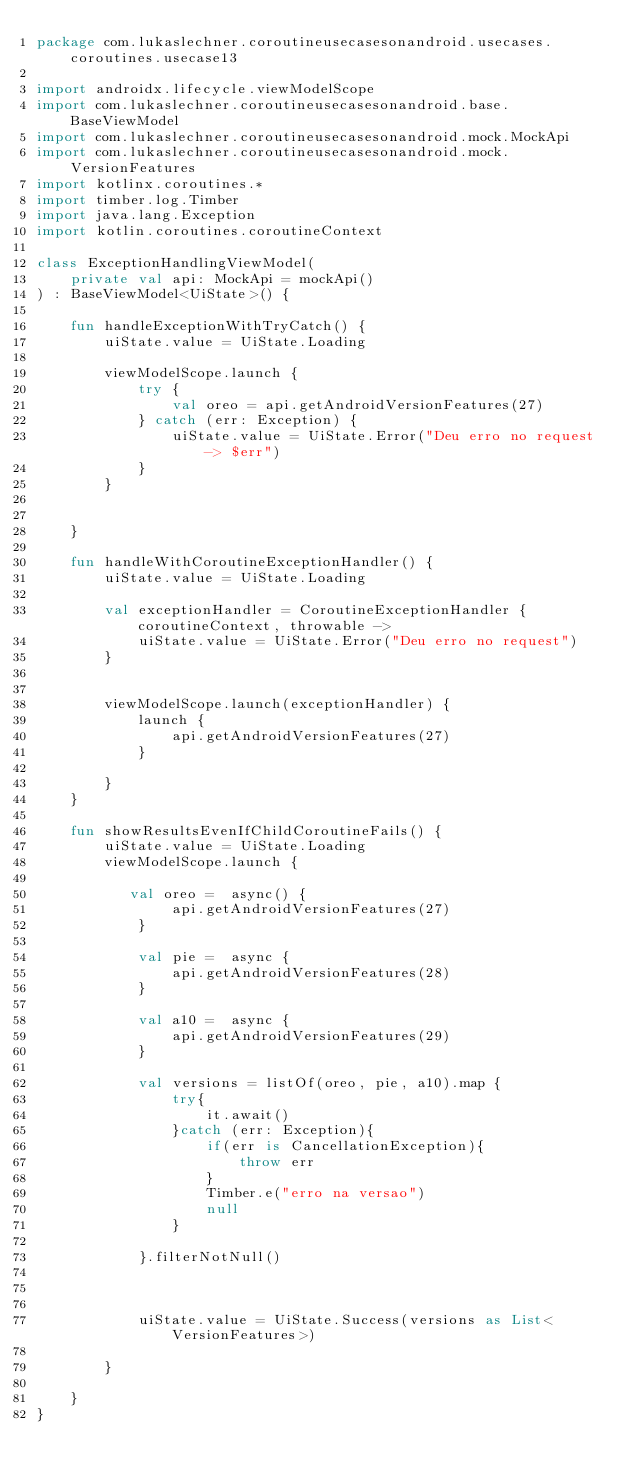Convert code to text. <code><loc_0><loc_0><loc_500><loc_500><_Kotlin_>package com.lukaslechner.coroutineusecasesonandroid.usecases.coroutines.usecase13

import androidx.lifecycle.viewModelScope
import com.lukaslechner.coroutineusecasesonandroid.base.BaseViewModel
import com.lukaslechner.coroutineusecasesonandroid.mock.MockApi
import com.lukaslechner.coroutineusecasesonandroid.mock.VersionFeatures
import kotlinx.coroutines.*
import timber.log.Timber
import java.lang.Exception
import kotlin.coroutines.coroutineContext

class ExceptionHandlingViewModel(
    private val api: MockApi = mockApi()
) : BaseViewModel<UiState>() {

    fun handleExceptionWithTryCatch() {
        uiState.value = UiState.Loading

        viewModelScope.launch {
            try {
                val oreo = api.getAndroidVersionFeatures(27)
            } catch (err: Exception) {
                uiState.value = UiState.Error("Deu erro no request -> $err")
            }
        }


    }

    fun handleWithCoroutineExceptionHandler() {
        uiState.value = UiState.Loading

        val exceptionHandler = CoroutineExceptionHandler { coroutineContext, throwable ->
            uiState.value = UiState.Error("Deu erro no request")
        }


        viewModelScope.launch(exceptionHandler) {
            launch {
                api.getAndroidVersionFeatures(27)
            }

        }
    }

    fun showResultsEvenIfChildCoroutineFails() {
        uiState.value = UiState.Loading
        viewModelScope.launch {

           val oreo =  async() {
                api.getAndroidVersionFeatures(27)
            }

            val pie =  async {
                api.getAndroidVersionFeatures(28)
            }

            val a10 =  async {
                api.getAndroidVersionFeatures(29)
            }

            val versions = listOf(oreo, pie, a10).map {
                try{
                    it.await()
                }catch (err: Exception){
                    if(err is CancellationException){
                        throw err
                    }
                    Timber.e("erro na versao")
                    null
                }

            }.filterNotNull()



            uiState.value = UiState.Success(versions as List<VersionFeatures>)

        }

    }
}</code> 